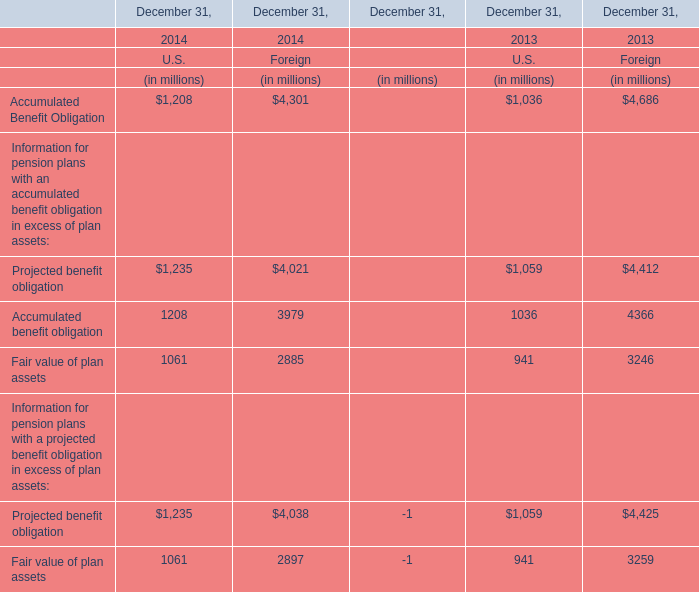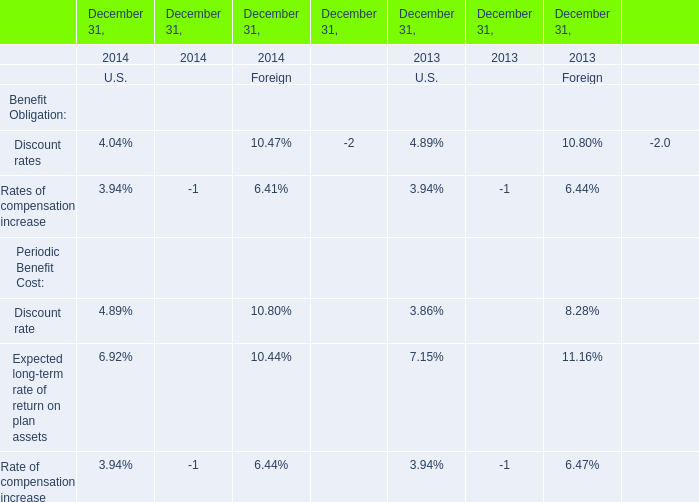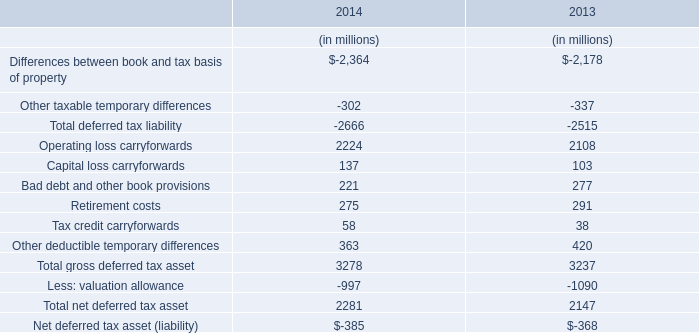Which year is U.S. Accumulated Benefit Obligation the highest? 
Answer: 2014. 